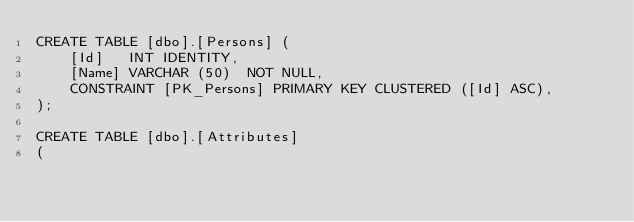Convert code to text. <code><loc_0><loc_0><loc_500><loc_500><_SQL_>CREATE TABLE [dbo].[Persons] (
    [Id]   INT IDENTITY,
    [Name] VARCHAR (50)  NOT NULL,
    CONSTRAINT [PK_Persons] PRIMARY KEY CLUSTERED ([Id] ASC),
);

CREATE TABLE [dbo].[Attributes]
(</code> 